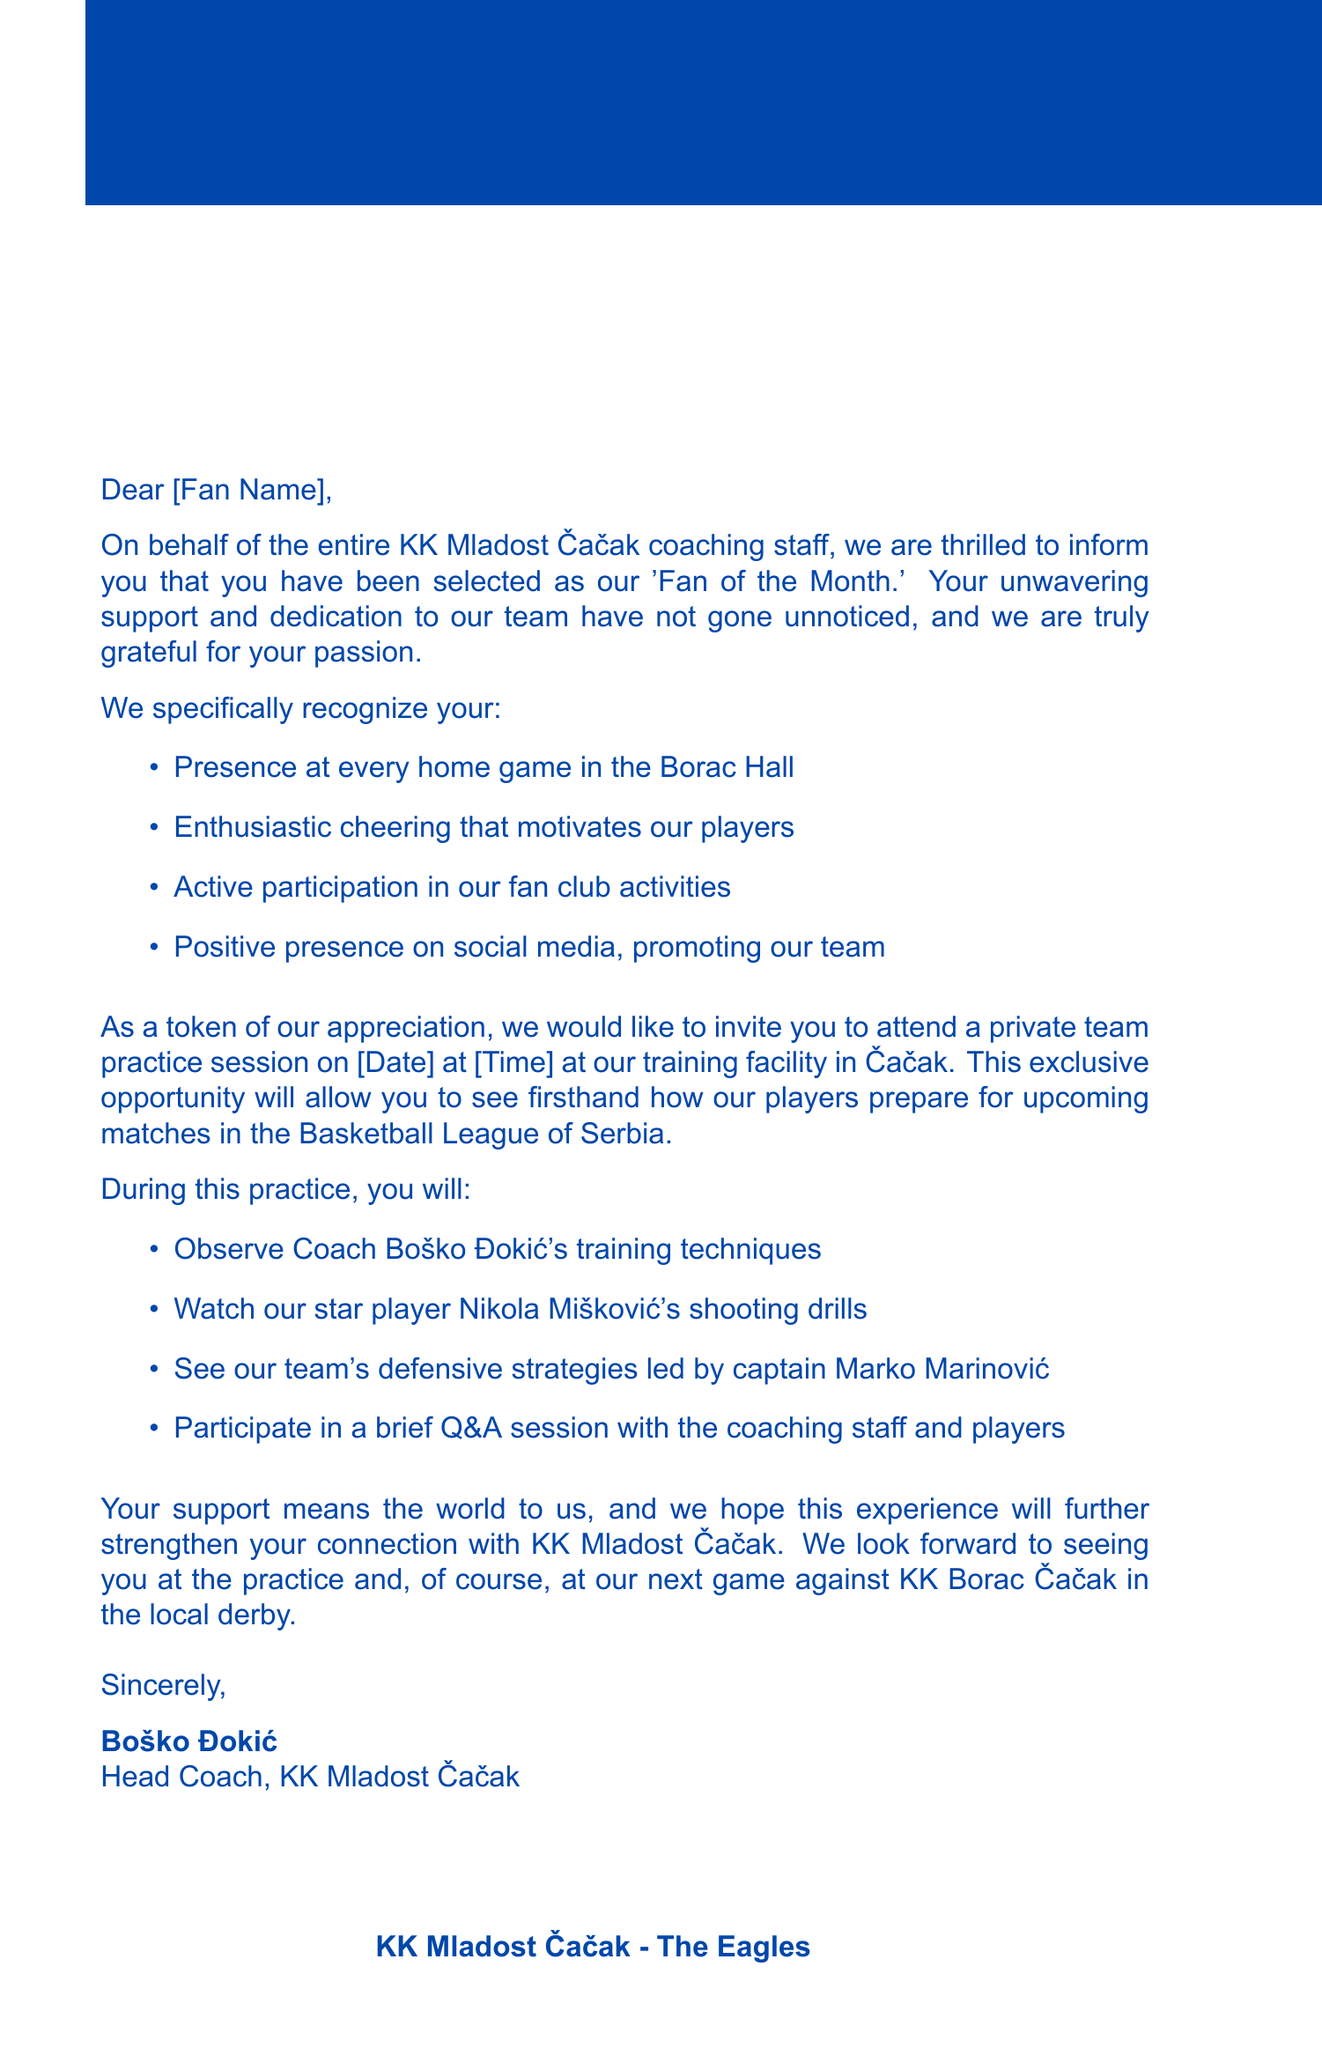What is the title of the recognition? The title of the recognition is mentioned in the document as 'Fan of the Month.'
Answer: Fan of the Month Who is the head coach of KK Mladost Čačak? The document names Boško Đokić as the head coach of KK Mladost Čačak, which is included in the signature section.
Answer: Boško Đokić What is the date of the private team practice? The document specifies that the practice will take place on [Date], which needs to be filled in.
Answer: [Date] What is the location of the practice? The location for the private practice is stated in the invitation paragraph as the training facility in Čačak.
Answer: training facility in Čačak How many recognition details are listed? The document provides four specific recognition details about the fan, as indicated in the list.
Answer: 4 What is one of the activities during the practice session? One of the activities mentioned is observing Coach Boško Đokić's training techniques.
Answer: Observe Coach Boško Đokić's training techniques What is the team nickname? The nickname for KK Mladost Čačak is provided in the additional information section of the letter.
Answer: The Eagles What event is suggested to attend after the practice? The document mentions a game against KK Borac Čačak as an upcoming event after the practice.
Answer: next game against KK Borac Čačak Where does the team play its home games? The Borac Hall is specified in the document as the location where the team plays its home games.
Answer: Borac Hall 